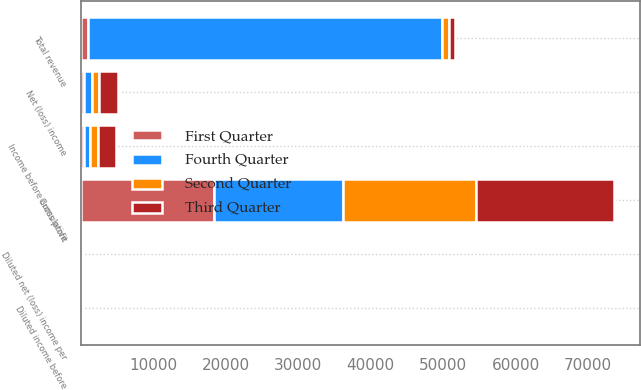<chart> <loc_0><loc_0><loc_500><loc_500><stacked_bar_chart><ecel><fcel>Total revenue<fcel>Gross profit<fcel>Income before cumulative<fcel>Net (loss) income<fcel>Diluted income before<fcel>Diluted net (loss) income per<nl><fcel>Fourth Quarter<fcel>49002<fcel>17795<fcel>874<fcel>1081<fcel>0.05<fcel>0.06<nl><fcel>First Quarter<fcel>874<fcel>18312<fcel>344<fcel>344<fcel>0.2<fcel>0.02<nl><fcel>Second Quarter<fcel>874<fcel>18480<fcel>1049<fcel>1019<fcel>0.05<fcel>0.05<nl><fcel>Third Quarter<fcel>874<fcel>18993<fcel>2599<fcel>2599<fcel>0.13<fcel>0.13<nl></chart> 